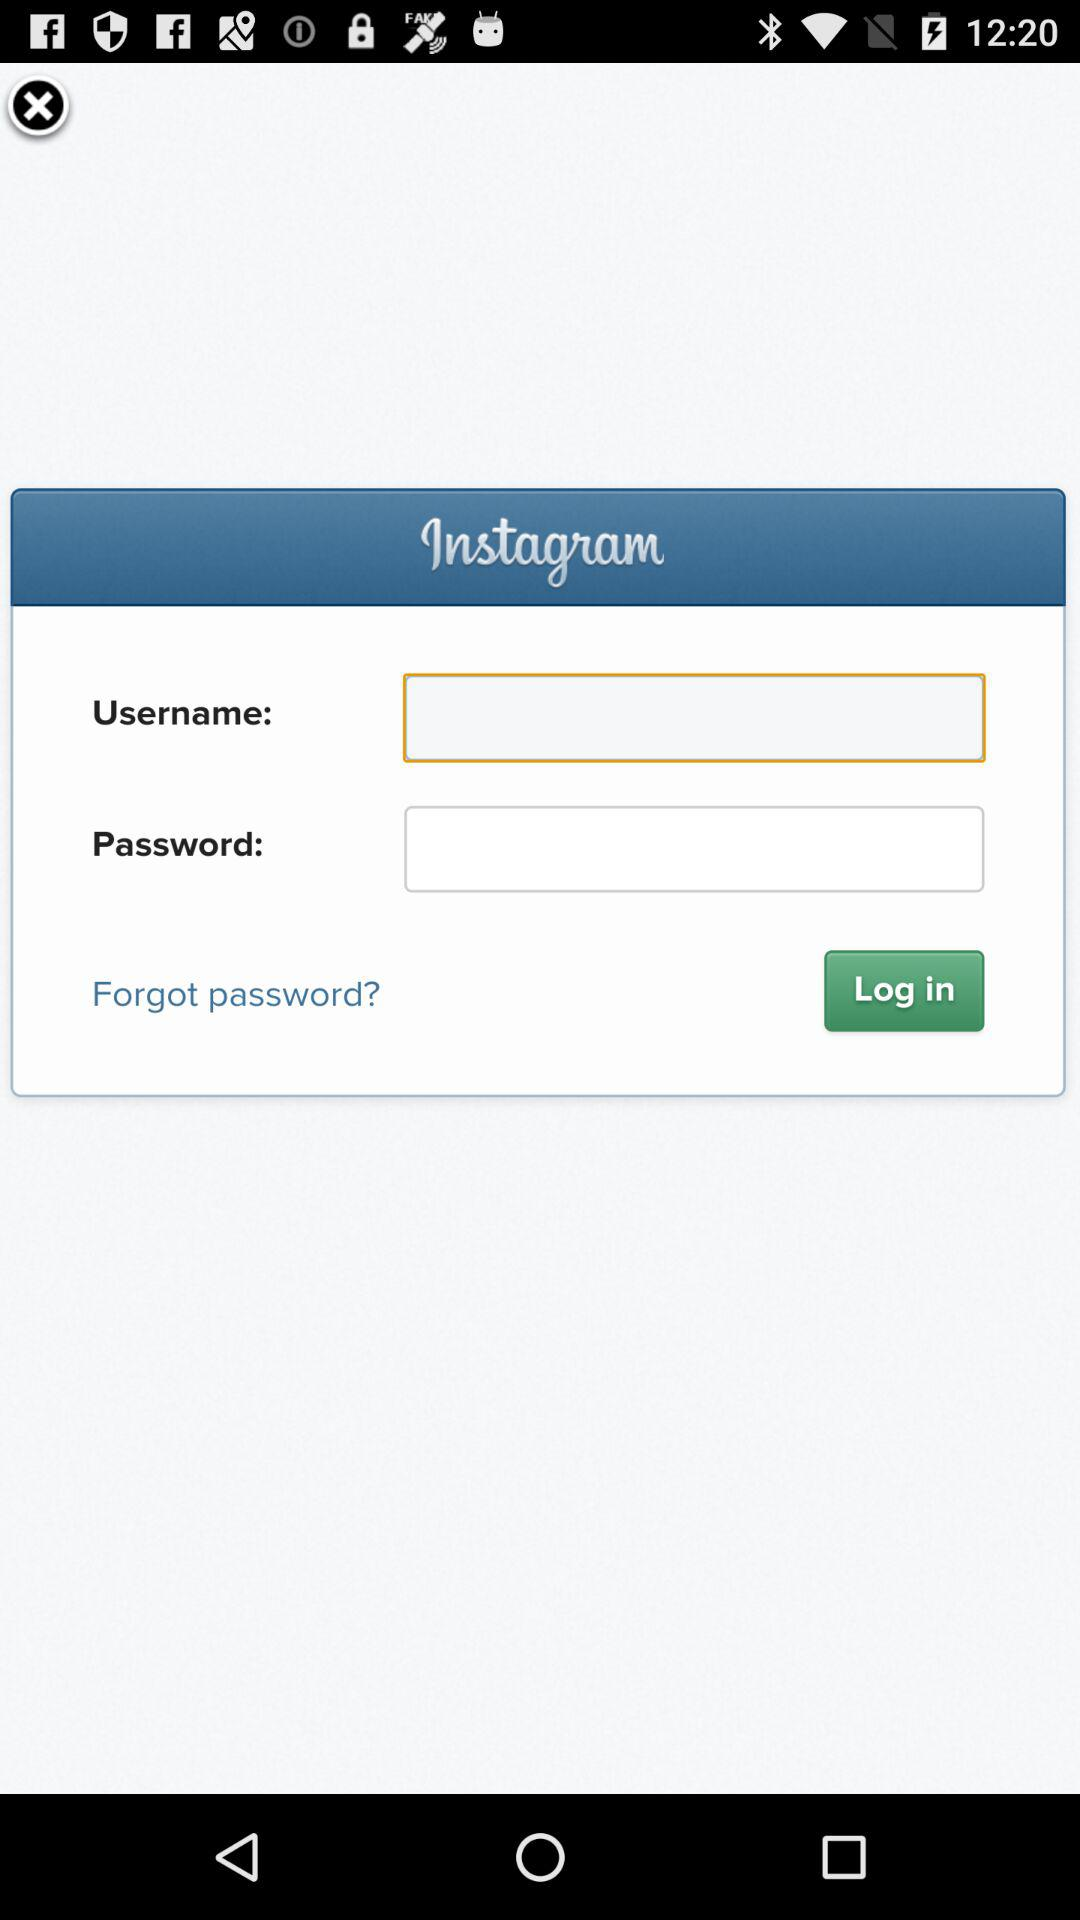Who is logging in?
When the provided information is insufficient, respond with <no answer>. <no answer> 